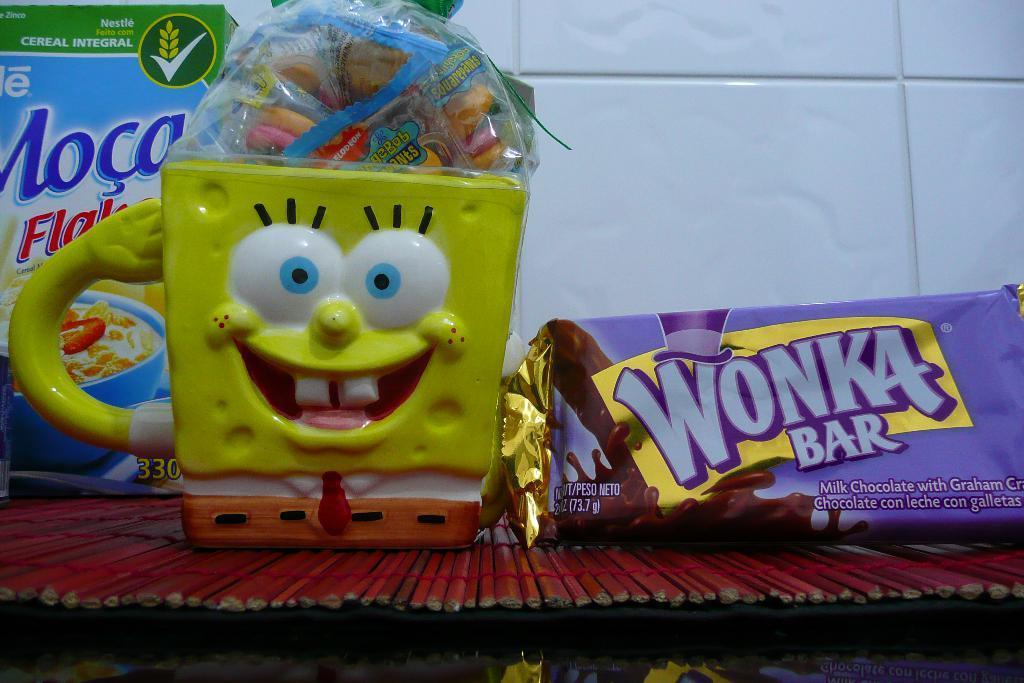Please provide a concise description of this image. In this image we can see a cup, candies, box and an object. In the background of the image there is a tiled wall. At the bottom of the image there is an object. 